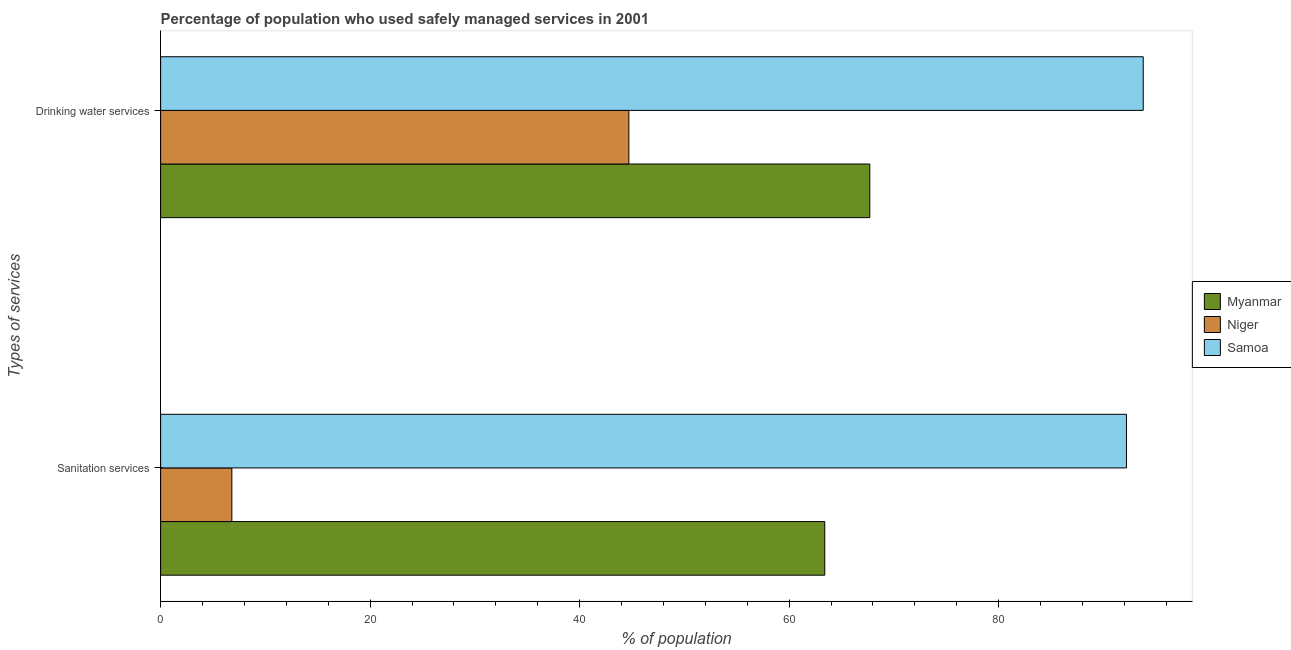Are the number of bars per tick equal to the number of legend labels?
Make the answer very short. Yes. Are the number of bars on each tick of the Y-axis equal?
Your answer should be very brief. Yes. How many bars are there on the 2nd tick from the top?
Give a very brief answer. 3. What is the label of the 2nd group of bars from the top?
Offer a terse response. Sanitation services. What is the percentage of population who used sanitation services in Myanmar?
Offer a terse response. 63.4. Across all countries, what is the maximum percentage of population who used sanitation services?
Make the answer very short. 92.2. Across all countries, what is the minimum percentage of population who used sanitation services?
Provide a short and direct response. 6.8. In which country was the percentage of population who used sanitation services maximum?
Offer a terse response. Samoa. In which country was the percentage of population who used sanitation services minimum?
Keep it short and to the point. Niger. What is the total percentage of population who used drinking water services in the graph?
Your answer should be compact. 206.2. What is the difference between the percentage of population who used sanitation services in Samoa and that in Niger?
Offer a terse response. 85.4. What is the difference between the percentage of population who used drinking water services in Samoa and the percentage of population who used sanitation services in Niger?
Your answer should be very brief. 87. What is the average percentage of population who used sanitation services per country?
Offer a very short reply. 54.13. What is the difference between the percentage of population who used sanitation services and percentage of population who used drinking water services in Niger?
Give a very brief answer. -37.9. What is the ratio of the percentage of population who used sanitation services in Niger to that in Samoa?
Your response must be concise. 0.07. In how many countries, is the percentage of population who used drinking water services greater than the average percentage of population who used drinking water services taken over all countries?
Your answer should be very brief. 1. What does the 3rd bar from the top in Drinking water services represents?
Provide a short and direct response. Myanmar. What does the 2nd bar from the bottom in Sanitation services represents?
Give a very brief answer. Niger. How many bars are there?
Your response must be concise. 6. Are all the bars in the graph horizontal?
Your response must be concise. Yes. What is the difference between two consecutive major ticks on the X-axis?
Provide a succinct answer. 20. Are the values on the major ticks of X-axis written in scientific E-notation?
Make the answer very short. No. How many legend labels are there?
Make the answer very short. 3. What is the title of the graph?
Make the answer very short. Percentage of population who used safely managed services in 2001. Does "Channel Islands" appear as one of the legend labels in the graph?
Give a very brief answer. No. What is the label or title of the X-axis?
Your response must be concise. % of population. What is the label or title of the Y-axis?
Keep it short and to the point. Types of services. What is the % of population in Myanmar in Sanitation services?
Offer a very short reply. 63.4. What is the % of population of Samoa in Sanitation services?
Make the answer very short. 92.2. What is the % of population in Myanmar in Drinking water services?
Ensure brevity in your answer.  67.7. What is the % of population in Niger in Drinking water services?
Provide a short and direct response. 44.7. What is the % of population in Samoa in Drinking water services?
Keep it short and to the point. 93.8. Across all Types of services, what is the maximum % of population in Myanmar?
Your response must be concise. 67.7. Across all Types of services, what is the maximum % of population in Niger?
Give a very brief answer. 44.7. Across all Types of services, what is the maximum % of population in Samoa?
Provide a short and direct response. 93.8. Across all Types of services, what is the minimum % of population in Myanmar?
Offer a terse response. 63.4. Across all Types of services, what is the minimum % of population in Samoa?
Ensure brevity in your answer.  92.2. What is the total % of population of Myanmar in the graph?
Your answer should be very brief. 131.1. What is the total % of population in Niger in the graph?
Your answer should be very brief. 51.5. What is the total % of population of Samoa in the graph?
Provide a short and direct response. 186. What is the difference between the % of population of Niger in Sanitation services and that in Drinking water services?
Keep it short and to the point. -37.9. What is the difference between the % of population in Samoa in Sanitation services and that in Drinking water services?
Your answer should be very brief. -1.6. What is the difference between the % of population in Myanmar in Sanitation services and the % of population in Samoa in Drinking water services?
Offer a terse response. -30.4. What is the difference between the % of population of Niger in Sanitation services and the % of population of Samoa in Drinking water services?
Offer a terse response. -87. What is the average % of population of Myanmar per Types of services?
Ensure brevity in your answer.  65.55. What is the average % of population of Niger per Types of services?
Offer a terse response. 25.75. What is the average % of population of Samoa per Types of services?
Give a very brief answer. 93. What is the difference between the % of population in Myanmar and % of population in Niger in Sanitation services?
Make the answer very short. 56.6. What is the difference between the % of population of Myanmar and % of population of Samoa in Sanitation services?
Make the answer very short. -28.8. What is the difference between the % of population of Niger and % of population of Samoa in Sanitation services?
Keep it short and to the point. -85.4. What is the difference between the % of population of Myanmar and % of population of Niger in Drinking water services?
Your answer should be compact. 23. What is the difference between the % of population of Myanmar and % of population of Samoa in Drinking water services?
Make the answer very short. -26.1. What is the difference between the % of population in Niger and % of population in Samoa in Drinking water services?
Provide a short and direct response. -49.1. What is the ratio of the % of population in Myanmar in Sanitation services to that in Drinking water services?
Ensure brevity in your answer.  0.94. What is the ratio of the % of population of Niger in Sanitation services to that in Drinking water services?
Your answer should be very brief. 0.15. What is the ratio of the % of population of Samoa in Sanitation services to that in Drinking water services?
Give a very brief answer. 0.98. What is the difference between the highest and the second highest % of population in Niger?
Make the answer very short. 37.9. What is the difference between the highest and the second highest % of population of Samoa?
Keep it short and to the point. 1.6. What is the difference between the highest and the lowest % of population in Myanmar?
Offer a very short reply. 4.3. What is the difference between the highest and the lowest % of population of Niger?
Give a very brief answer. 37.9. 